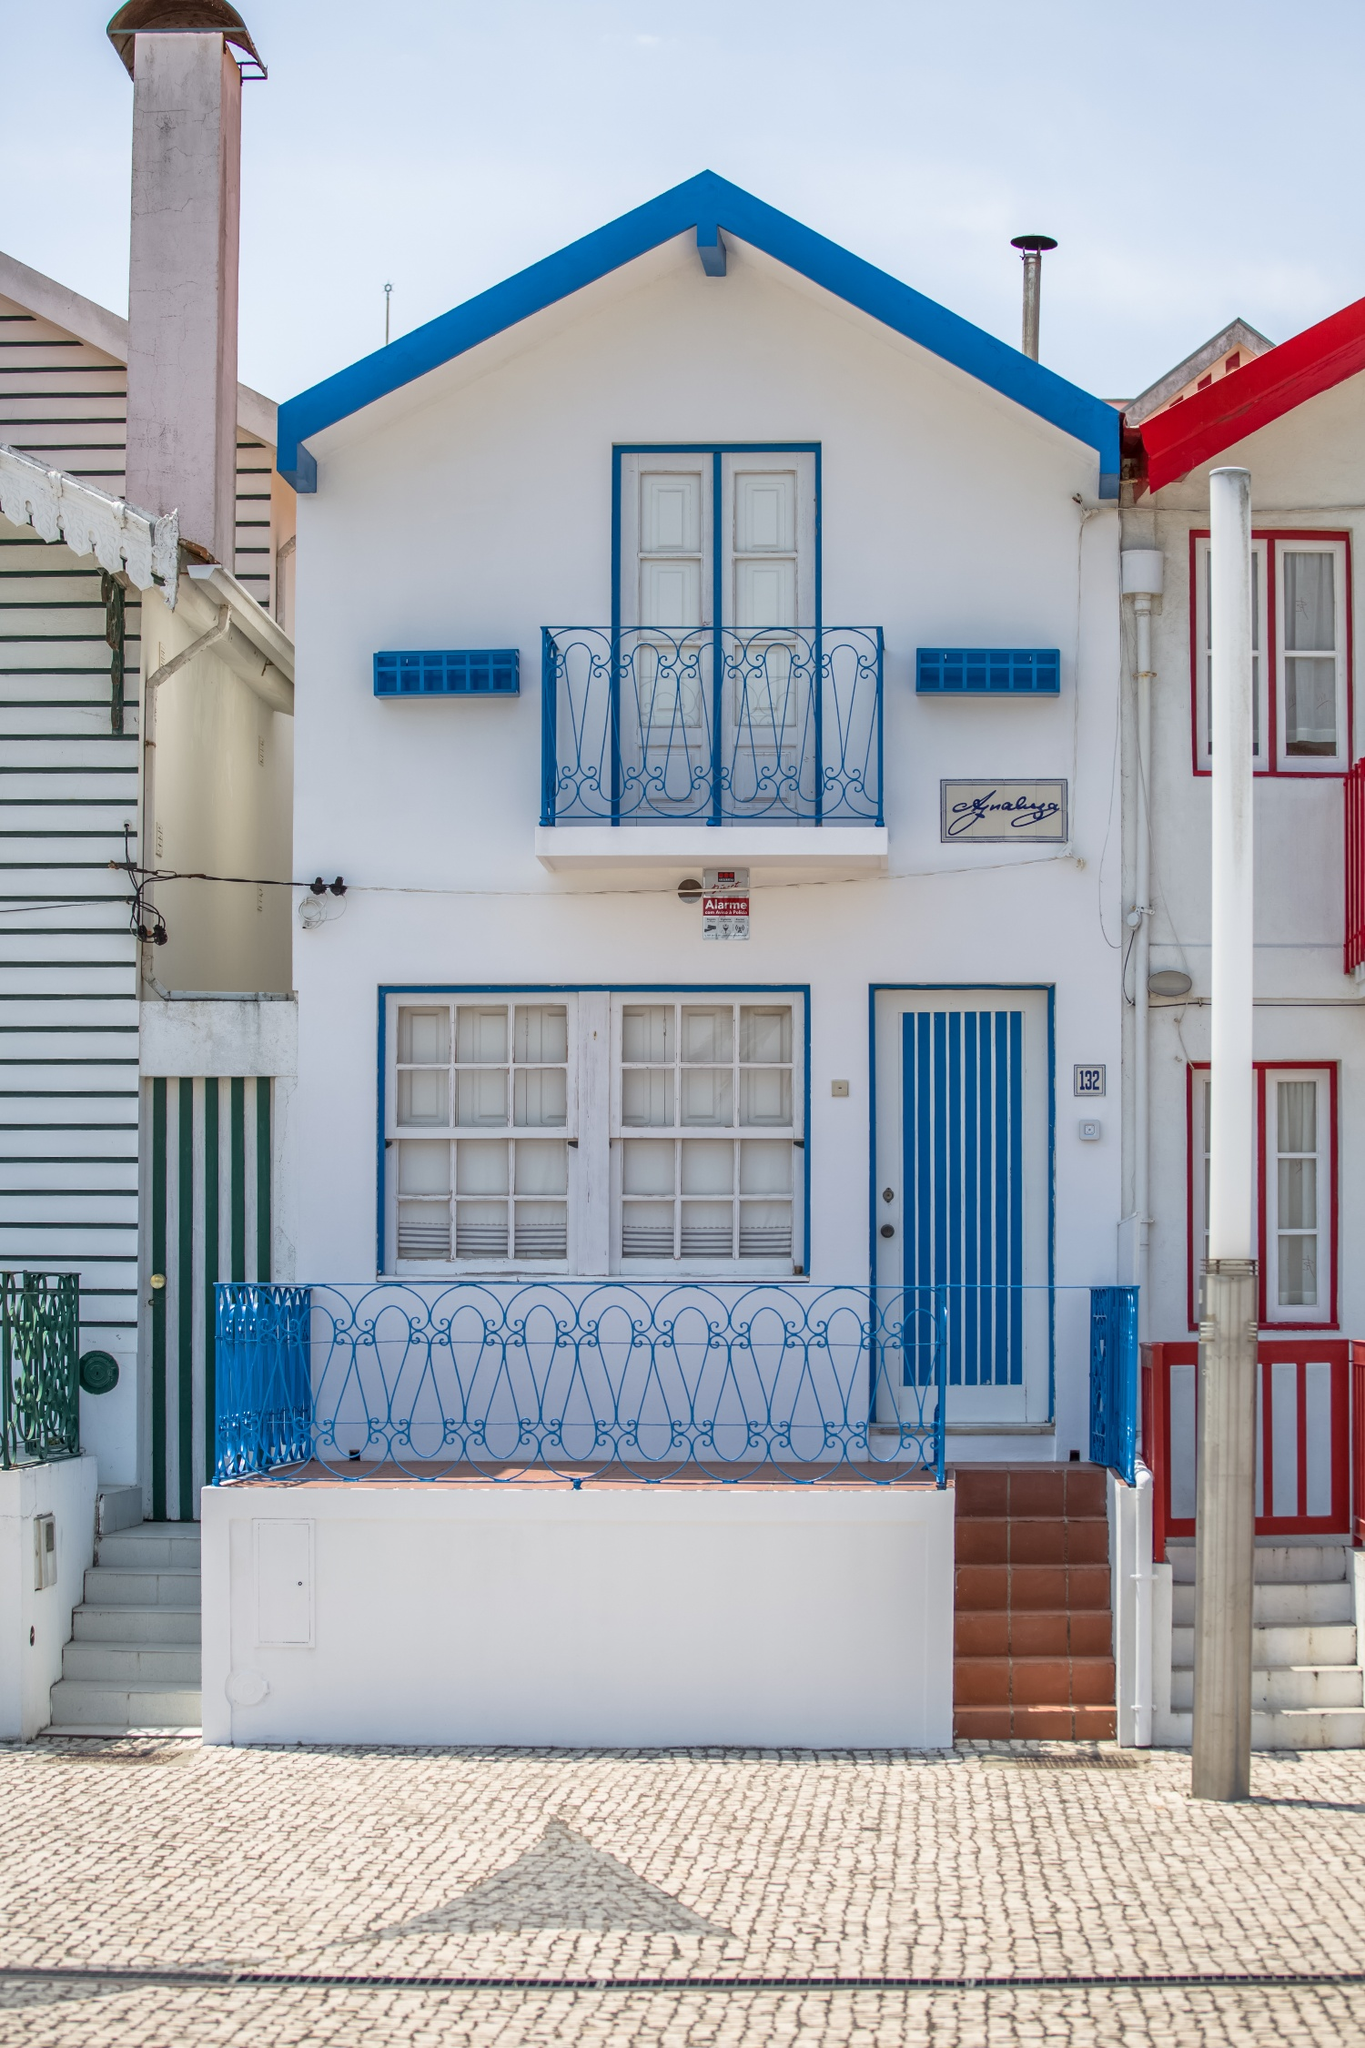How does the architectural style of this house compare to typical homes in coastal European towns? This house's architectural style is quite representative of many coastal towns in Europe, particularly with its use of bright colors and tiled roofs which are common in such regions. The compact, high-density layout and decorative elements like the ornate balconies also suggest influences from Mediterranean or Southern European styles. This design is practical yet charming, maximizing space while beautifying the urban landscape. 